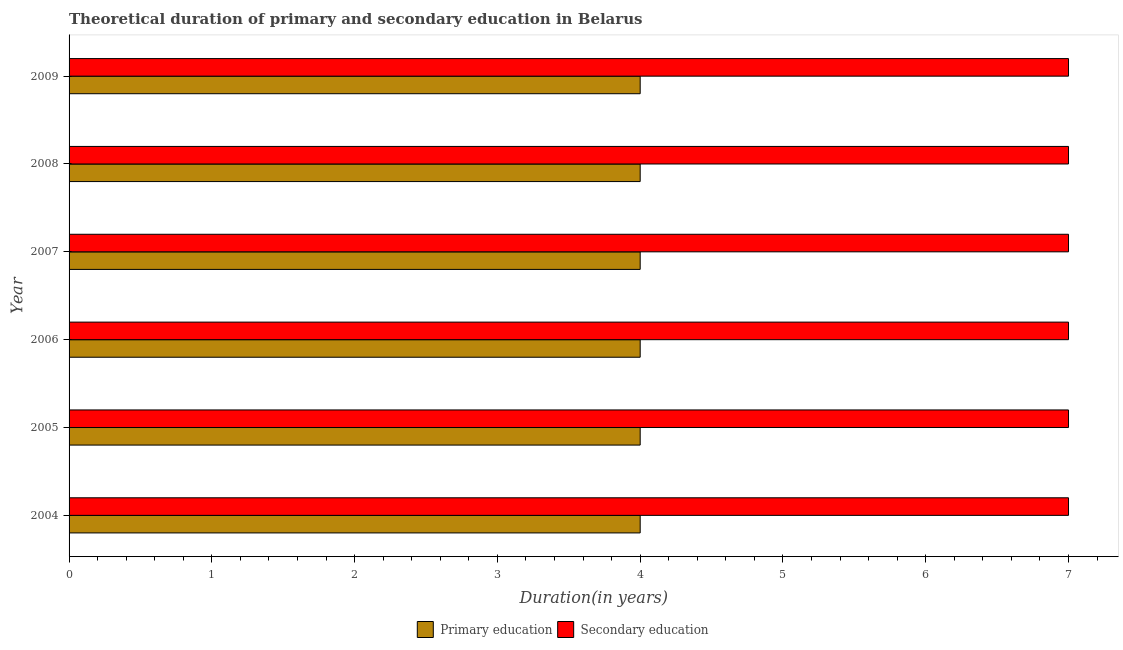Are the number of bars on each tick of the Y-axis equal?
Offer a very short reply. Yes. How many bars are there on the 2nd tick from the top?
Ensure brevity in your answer.  2. How many bars are there on the 3rd tick from the bottom?
Your answer should be compact. 2. What is the label of the 2nd group of bars from the top?
Provide a short and direct response. 2008. What is the duration of primary education in 2004?
Provide a succinct answer. 4. Across all years, what is the maximum duration of secondary education?
Offer a very short reply. 7. Across all years, what is the minimum duration of secondary education?
Your answer should be very brief. 7. What is the total duration of secondary education in the graph?
Make the answer very short. 42. What is the difference between the duration of primary education in 2008 and the duration of secondary education in 2004?
Your answer should be compact. -3. In the year 2008, what is the difference between the duration of primary education and duration of secondary education?
Provide a short and direct response. -3. Is the duration of primary education in 2004 less than that in 2005?
Ensure brevity in your answer.  No. What is the difference between the highest and the lowest duration of secondary education?
Your answer should be compact. 0. Is the sum of the duration of secondary education in 2005 and 2006 greater than the maximum duration of primary education across all years?
Provide a short and direct response. Yes. What does the 1st bar from the top in 2007 represents?
Ensure brevity in your answer.  Secondary education. What does the 2nd bar from the bottom in 2007 represents?
Offer a very short reply. Secondary education. Are all the bars in the graph horizontal?
Your answer should be compact. Yes. How many years are there in the graph?
Offer a terse response. 6. What is the difference between two consecutive major ticks on the X-axis?
Your response must be concise. 1. Are the values on the major ticks of X-axis written in scientific E-notation?
Ensure brevity in your answer.  No. Does the graph contain any zero values?
Your response must be concise. No. Does the graph contain grids?
Keep it short and to the point. No. Where does the legend appear in the graph?
Your answer should be compact. Bottom center. How many legend labels are there?
Your response must be concise. 2. What is the title of the graph?
Provide a succinct answer. Theoretical duration of primary and secondary education in Belarus. What is the label or title of the X-axis?
Make the answer very short. Duration(in years). What is the Duration(in years) in Secondary education in 2006?
Your answer should be very brief. 7. What is the Duration(in years) in Secondary education in 2007?
Provide a short and direct response. 7. What is the Duration(in years) in Secondary education in 2008?
Provide a succinct answer. 7. What is the Duration(in years) in Primary education in 2009?
Ensure brevity in your answer.  4. What is the Duration(in years) of Secondary education in 2009?
Provide a succinct answer. 7. Across all years, what is the minimum Duration(in years) of Primary education?
Your response must be concise. 4. What is the total Duration(in years) in Primary education in the graph?
Your answer should be very brief. 24. What is the difference between the Duration(in years) in Secondary education in 2004 and that in 2005?
Keep it short and to the point. 0. What is the difference between the Duration(in years) of Primary education in 2004 and that in 2007?
Make the answer very short. 0. What is the difference between the Duration(in years) of Secondary education in 2004 and that in 2008?
Provide a succinct answer. 0. What is the difference between the Duration(in years) in Primary education in 2004 and that in 2009?
Offer a terse response. 0. What is the difference between the Duration(in years) in Secondary education in 2004 and that in 2009?
Offer a terse response. 0. What is the difference between the Duration(in years) in Primary education in 2005 and that in 2006?
Keep it short and to the point. 0. What is the difference between the Duration(in years) in Secondary education in 2005 and that in 2006?
Provide a succinct answer. 0. What is the difference between the Duration(in years) of Primary education in 2005 and that in 2007?
Make the answer very short. 0. What is the difference between the Duration(in years) of Secondary education in 2005 and that in 2007?
Your response must be concise. 0. What is the difference between the Duration(in years) in Primary education in 2005 and that in 2008?
Keep it short and to the point. 0. What is the difference between the Duration(in years) of Primary education in 2005 and that in 2009?
Provide a short and direct response. 0. What is the difference between the Duration(in years) in Secondary education in 2006 and that in 2008?
Give a very brief answer. 0. What is the difference between the Duration(in years) in Primary education in 2007 and that in 2008?
Offer a terse response. 0. What is the difference between the Duration(in years) of Primary education in 2007 and that in 2009?
Offer a very short reply. 0. What is the difference between the Duration(in years) in Primary education in 2004 and the Duration(in years) in Secondary education in 2006?
Offer a terse response. -3. What is the difference between the Duration(in years) in Primary education in 2005 and the Duration(in years) in Secondary education in 2006?
Give a very brief answer. -3. What is the difference between the Duration(in years) in Primary education in 2005 and the Duration(in years) in Secondary education in 2007?
Your answer should be compact. -3. What is the difference between the Duration(in years) in Primary education in 2005 and the Duration(in years) in Secondary education in 2008?
Make the answer very short. -3. What is the difference between the Duration(in years) in Primary education in 2006 and the Duration(in years) in Secondary education in 2008?
Provide a short and direct response. -3. What is the difference between the Duration(in years) in Primary education in 2007 and the Duration(in years) in Secondary education in 2009?
Give a very brief answer. -3. What is the average Duration(in years) of Secondary education per year?
Offer a very short reply. 7. In the year 2004, what is the difference between the Duration(in years) in Primary education and Duration(in years) in Secondary education?
Your answer should be compact. -3. In the year 2007, what is the difference between the Duration(in years) in Primary education and Duration(in years) in Secondary education?
Keep it short and to the point. -3. In the year 2008, what is the difference between the Duration(in years) of Primary education and Duration(in years) of Secondary education?
Provide a short and direct response. -3. In the year 2009, what is the difference between the Duration(in years) of Primary education and Duration(in years) of Secondary education?
Offer a very short reply. -3. What is the ratio of the Duration(in years) of Secondary education in 2004 to that in 2005?
Your response must be concise. 1. What is the ratio of the Duration(in years) of Primary education in 2004 to that in 2007?
Ensure brevity in your answer.  1. What is the ratio of the Duration(in years) in Secondary education in 2004 to that in 2007?
Make the answer very short. 1. What is the ratio of the Duration(in years) of Secondary education in 2004 to that in 2008?
Give a very brief answer. 1. What is the ratio of the Duration(in years) of Secondary education in 2004 to that in 2009?
Keep it short and to the point. 1. What is the ratio of the Duration(in years) of Secondary education in 2005 to that in 2006?
Your answer should be very brief. 1. What is the ratio of the Duration(in years) in Primary education in 2005 to that in 2007?
Offer a terse response. 1. What is the ratio of the Duration(in years) of Secondary education in 2005 to that in 2007?
Provide a short and direct response. 1. What is the ratio of the Duration(in years) of Primary education in 2005 to that in 2008?
Your answer should be compact. 1. What is the ratio of the Duration(in years) in Secondary education in 2005 to that in 2009?
Your response must be concise. 1. What is the ratio of the Duration(in years) in Primary education in 2006 to that in 2009?
Your answer should be compact. 1. What is the ratio of the Duration(in years) in Primary education in 2007 to that in 2008?
Make the answer very short. 1. What is the ratio of the Duration(in years) in Secondary education in 2007 to that in 2008?
Offer a terse response. 1. What is the ratio of the Duration(in years) of Primary education in 2007 to that in 2009?
Your answer should be compact. 1. What is the ratio of the Duration(in years) in Primary education in 2008 to that in 2009?
Keep it short and to the point. 1. What is the ratio of the Duration(in years) of Secondary education in 2008 to that in 2009?
Make the answer very short. 1. What is the difference between the highest and the second highest Duration(in years) in Secondary education?
Provide a succinct answer. 0. What is the difference between the highest and the lowest Duration(in years) of Secondary education?
Your response must be concise. 0. 